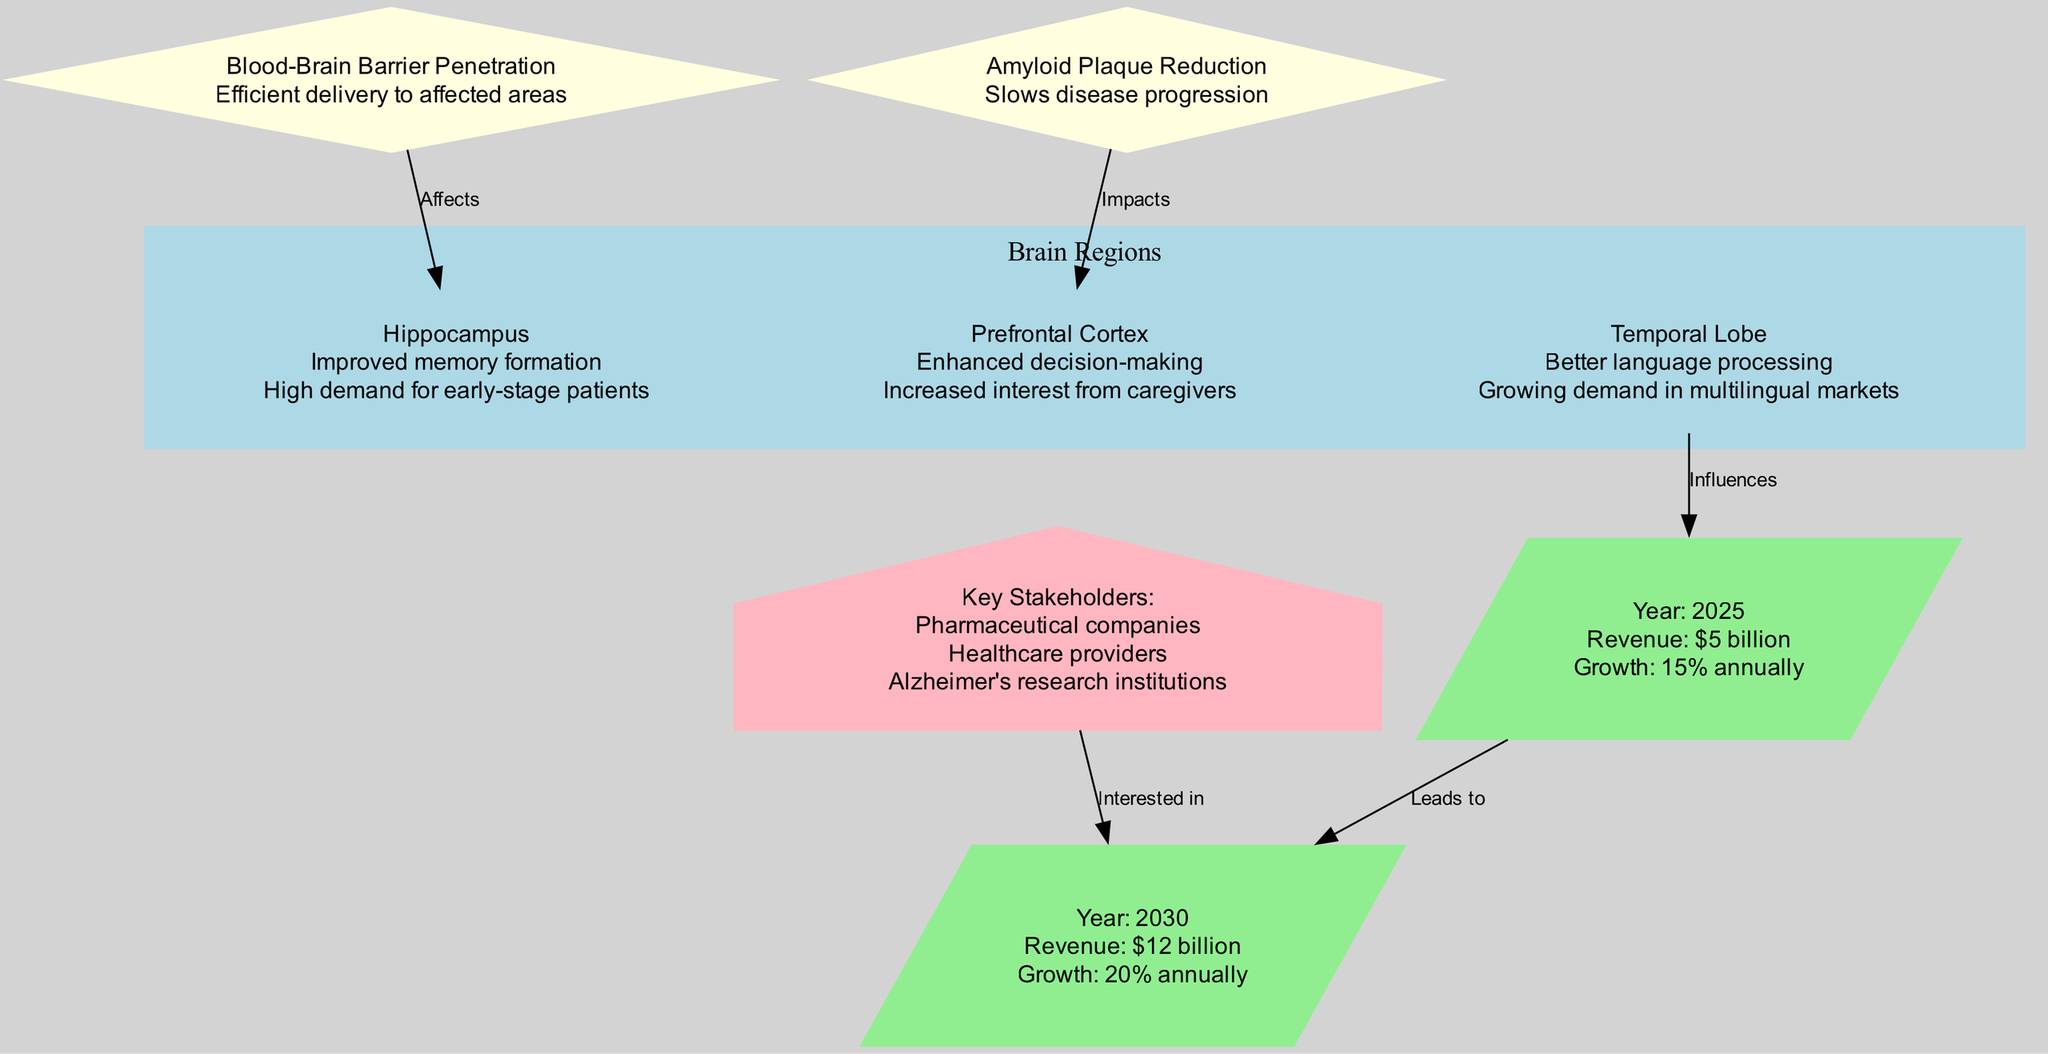What are the effects in the Hippocampus? The diagram states that the effect in the Hippocampus is "Improved memory formation". This can be found directly under the Hippocampus node.
Answer: Improved memory formation What is the market impact of the Prefrontal Cortex? Under the Prefrontal Cortex, it is mentioned that there is "Increased interest from caregivers". This is indicated in the market impact for this brain region.
Answer: Increased interest from caregivers How many brain regions are shown in the diagram? The diagram lists three brain regions: Hippocampus, Prefrontal Cortex, and Temporal Lobe. The count is derived from the individual nodes displayed under the brain regions subgraph.
Answer: 3 What is the projected revenue for the market in 2030? The diagram indicates that the projected revenue for the market in 2030 is "$12 billion". This value can be found in the node labeled "Market 2030".
Answer: $12 billion What does Amyloid Plaque Reduction impact according to the diagram? The edge connecting "Amyloid Plaque Reduction" to "Prefrontal Cortex" states that it "Impacts" this brain region, indicating a direct relationship in the diagram.
Answer: Prefrontal Cortex How does the Blood-Brain Barrier Penetration relate to the Hippocampus? The diagram shows an edge from "Blood-Brain Barrier Penetration" to "Hippocampus" with the label "Affects". This indicates that the drug's ability to penetrate the blood-brain barrier influences this brain region.
Answer: Affects What is the annual growth rate projected between 2025 and 2030? The growth rate in 2030 is stated as "20% annually", while it is "15% annually" for 2025. The rate between these years can be compared to show the trend, but is not explicitly mentioned in the diagram as a change.
Answer: 20% annually Who are the key stakeholders listed in the diagram? The node labeled "Key Stakeholders" lists the stakeholders as "Pharmaceutical companies", "Healthcare providers", and "Alzheimer's research institutions", all of which are shown within that node.
Answer: Pharmaceutical companies, Healthcare providers, Alzheimer's research institutions 